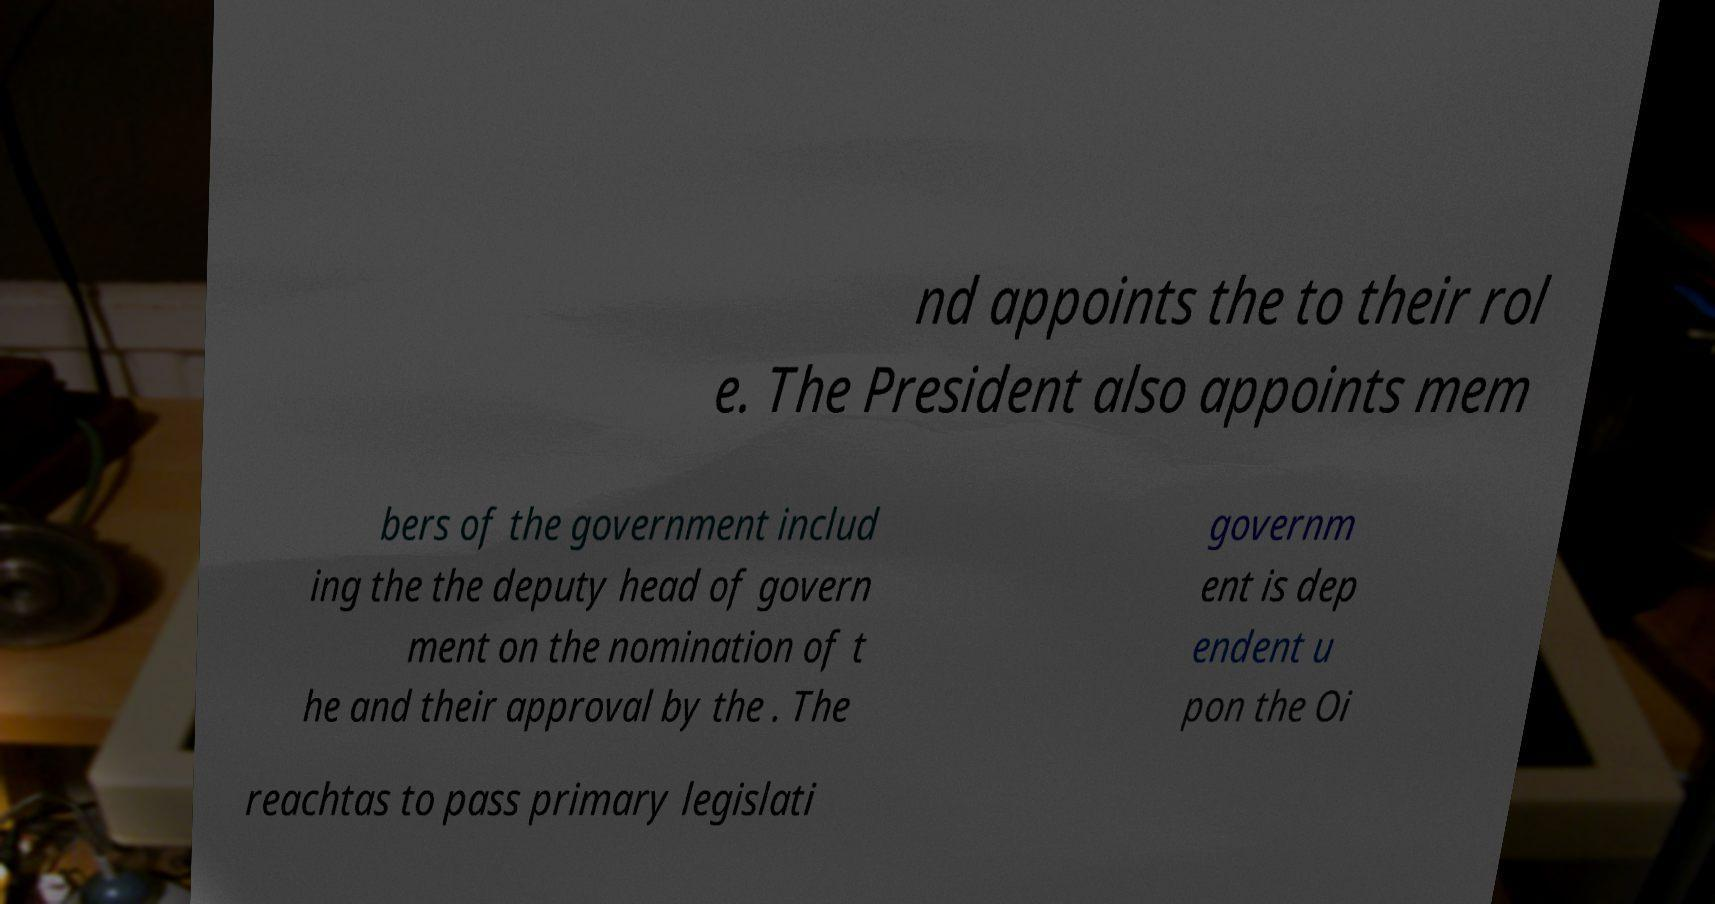Could you assist in decoding the text presented in this image and type it out clearly? nd appoints the to their rol e. The President also appoints mem bers of the government includ ing the the deputy head of govern ment on the nomination of t he and their approval by the . The governm ent is dep endent u pon the Oi reachtas to pass primary legislati 